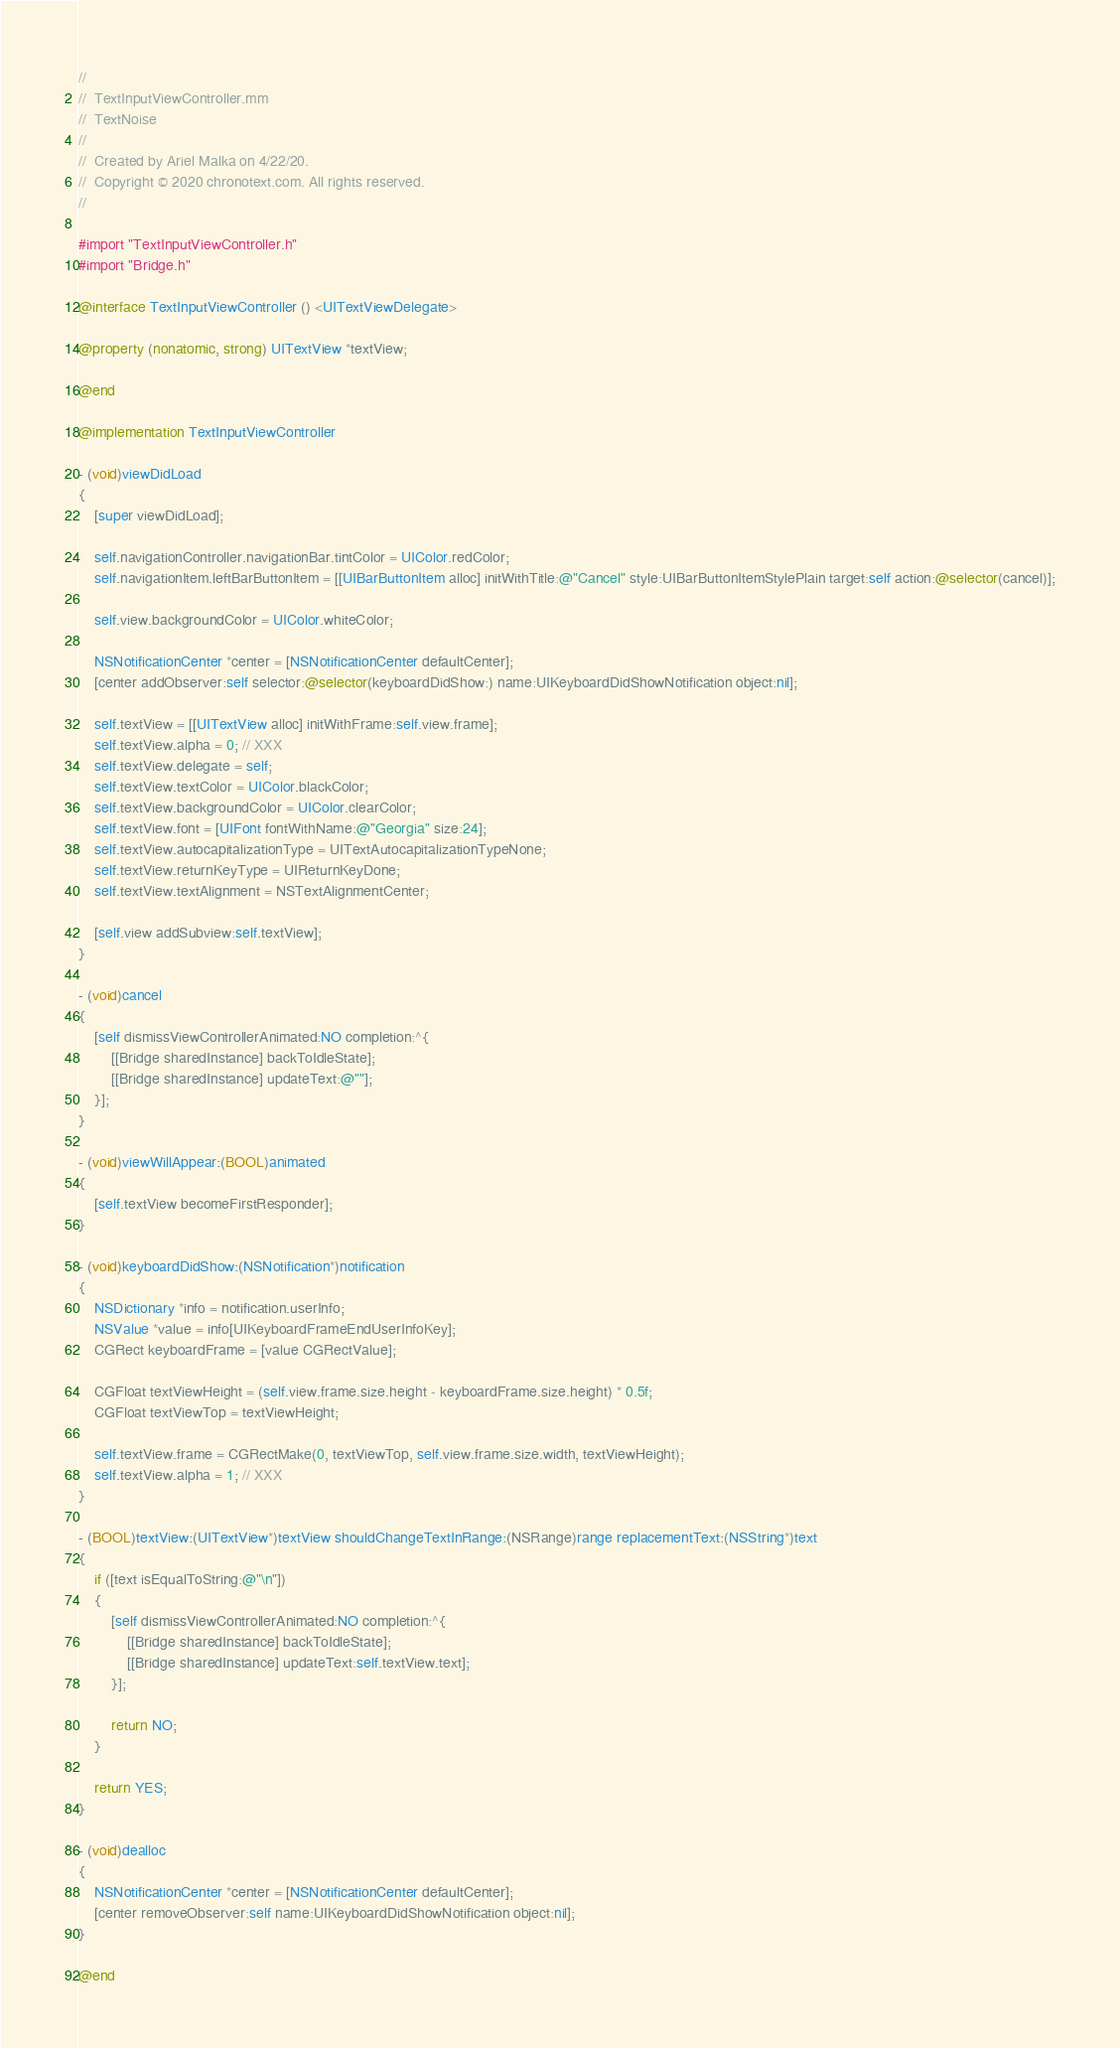<code> <loc_0><loc_0><loc_500><loc_500><_ObjectiveC_>//
//  TextInputViewController.mm
//  TextNoise
//
//  Created by Ariel Malka on 4/22/20.
//  Copyright © 2020 chronotext.com. All rights reserved.
//

#import "TextInputViewController.h"
#import "Bridge.h"

@interface TextInputViewController () <UITextViewDelegate>

@property (nonatomic, strong) UITextView *textView;

@end

@implementation TextInputViewController

- (void)viewDidLoad
{
    [super viewDidLoad];
    
    self.navigationController.navigationBar.tintColor = UIColor.redColor;
    self.navigationItem.leftBarButtonItem = [[UIBarButtonItem alloc] initWithTitle:@"Cancel" style:UIBarButtonItemStylePlain target:self action:@selector(cancel)];
    
    self.view.backgroundColor = UIColor.whiteColor;
    
    NSNotificationCenter *center = [NSNotificationCenter defaultCenter];
    [center addObserver:self selector:@selector(keyboardDidShow:) name:UIKeyboardDidShowNotification object:nil];
    
    self.textView = [[UITextView alloc] initWithFrame:self.view.frame];
    self.textView.alpha = 0; // XXX
    self.textView.delegate = self;
    self.textView.textColor = UIColor.blackColor;
    self.textView.backgroundColor = UIColor.clearColor;
    self.textView.font = [UIFont fontWithName:@"Georgia" size:24];
    self.textView.autocapitalizationType = UITextAutocapitalizationTypeNone;
    self.textView.returnKeyType = UIReturnKeyDone;
    self.textView.textAlignment = NSTextAlignmentCenter;
    
    [self.view addSubview:self.textView];
}

- (void)cancel
{
    [self dismissViewControllerAnimated:NO completion:^{
        [[Bridge sharedInstance] backToIdleState];
        [[Bridge sharedInstance] updateText:@""];
    }];
}

- (void)viewWillAppear:(BOOL)animated
{
    [self.textView becomeFirstResponder];
}

- (void)keyboardDidShow:(NSNotification*)notification
{
    NSDictionary *info = notification.userInfo;
    NSValue *value = info[UIKeyboardFrameEndUserInfoKey];
    CGRect keyboardFrame = [value CGRectValue];

    CGFloat textViewHeight = (self.view.frame.size.height - keyboardFrame.size.height) * 0.5f;
    CGFloat textViewTop = textViewHeight;
    
    self.textView.frame = CGRectMake(0, textViewTop, self.view.frame.size.width, textViewHeight);
    self.textView.alpha = 1; // XXX
}

- (BOOL)textView:(UITextView*)textView shouldChangeTextInRange:(NSRange)range replacementText:(NSString*)text
{
    if ([text isEqualToString:@"\n"])
    {
        [self dismissViewControllerAnimated:NO completion:^{
            [[Bridge sharedInstance] backToIdleState];
            [[Bridge sharedInstance] updateText:self.textView.text];
        }];

        return NO;
    }

    return YES;
}

- (void)dealloc
{
    NSNotificationCenter *center = [NSNotificationCenter defaultCenter];
    [center removeObserver:self name:UIKeyboardDidShowNotification object:nil];
}

@end
</code> 